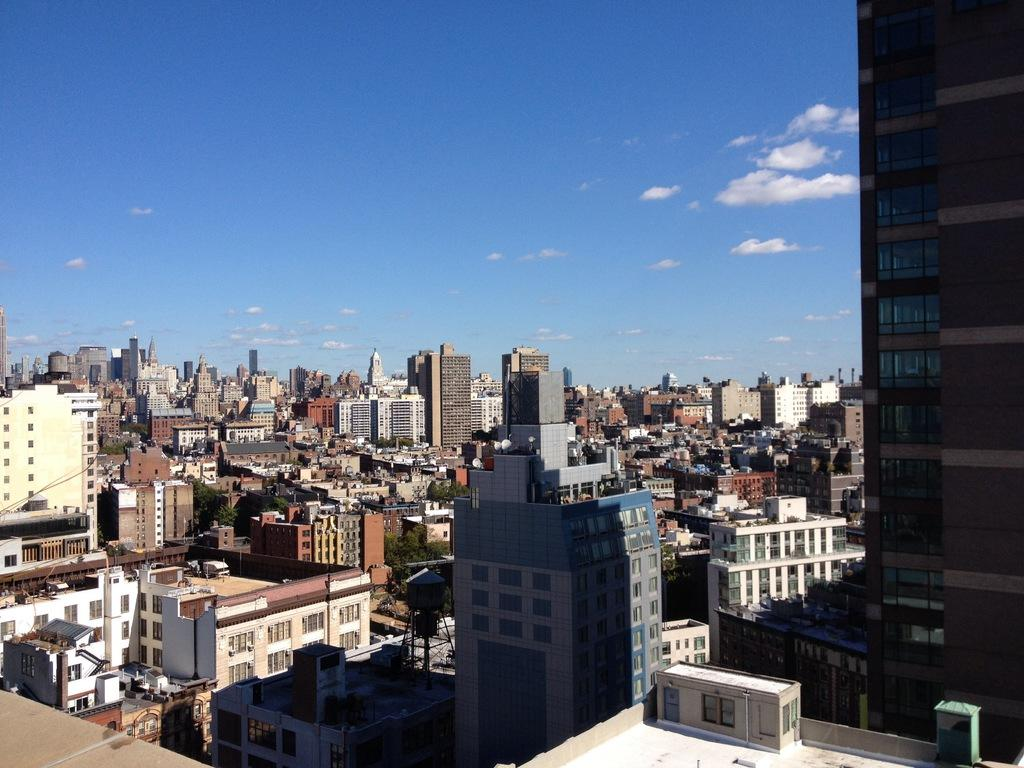What is the primary subject of the image? There are many buildings in the image. What can be seen in the sky in the image? There are clouds visible in the sky in the image. Can you tell me how many spiders are crawling on the buildings in the image? There are no spiders visible on the buildings in the image. What type of sense is being used by the clouds in the image? Clouds do not have senses, as they are inanimate objects. 